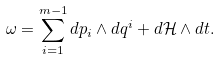<formula> <loc_0><loc_0><loc_500><loc_500>\omega = \sum _ { i = 1 } ^ { m - 1 } d p _ { i } \wedge d q ^ { i } + d \mathcal { H } \wedge d t .</formula> 